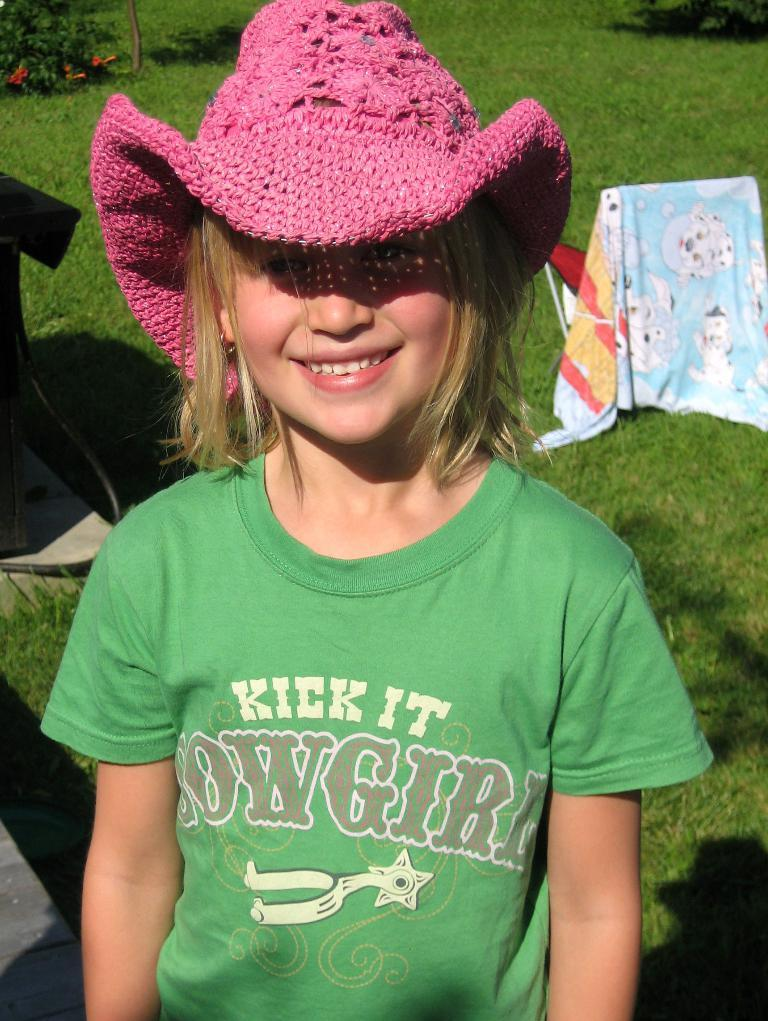What is the main subject in the center of the image? There is a kid in the center of the image. What can be seen in the background of the image? There is a chair, grass, and plants in the background of the image. How many dimes can be seen on the edge of the chair in the image? There are no dimes present in the image, and therefore no such objects can be observed on the edge of the chair. 